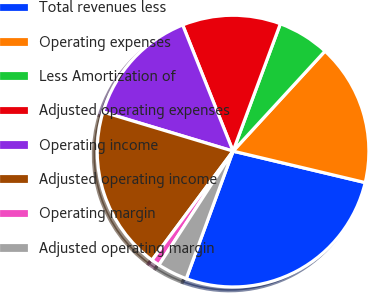Convert chart to OTSL. <chart><loc_0><loc_0><loc_500><loc_500><pie_chart><fcel>Total revenues less<fcel>Operating expenses<fcel>Less Amortization of<fcel>Adjusted operating expenses<fcel>Operating income<fcel>Adjusted operating income<fcel>Operating margin<fcel>Adjusted operating margin<nl><fcel>26.88%<fcel>16.89%<fcel>6.17%<fcel>11.71%<fcel>14.3%<fcel>19.48%<fcel>0.99%<fcel>3.58%<nl></chart> 